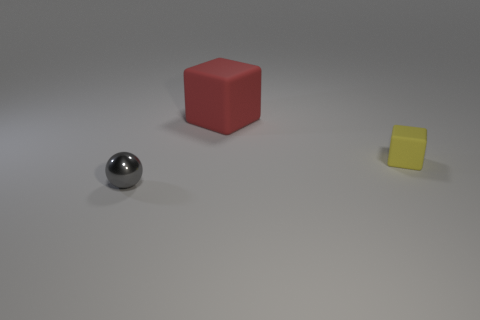Add 2 red matte objects. How many objects exist? 5 Subtract all blocks. How many objects are left? 1 Subtract all tiny shiny spheres. Subtract all small objects. How many objects are left? 0 Add 3 shiny balls. How many shiny balls are left? 4 Add 1 large blue metal spheres. How many large blue metal spheres exist? 1 Subtract 0 red balls. How many objects are left? 3 